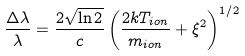<formula> <loc_0><loc_0><loc_500><loc_500>\frac { \Delta \lambda } { \lambda } = \frac { 2 \sqrt { \ln 2 } } { c } \left ( \frac { 2 k T _ { i o n } } { m _ { i o n } } + \xi ^ { 2 } \right ) ^ { 1 / 2 }</formula> 